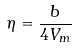<formula> <loc_0><loc_0><loc_500><loc_500>\eta = \frac { b } { 4 V _ { m } }</formula> 